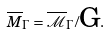<formula> <loc_0><loc_0><loc_500><loc_500>\overline { M } _ { \Gamma } = { \overline { \mathcal { M } } } _ { \Gamma } / { \text  G}.</formula> 